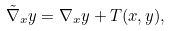Convert formula to latex. <formula><loc_0><loc_0><loc_500><loc_500>\tilde { \nabla } _ { x } y = \nabla _ { x } y + T ( x , y ) ,</formula> 